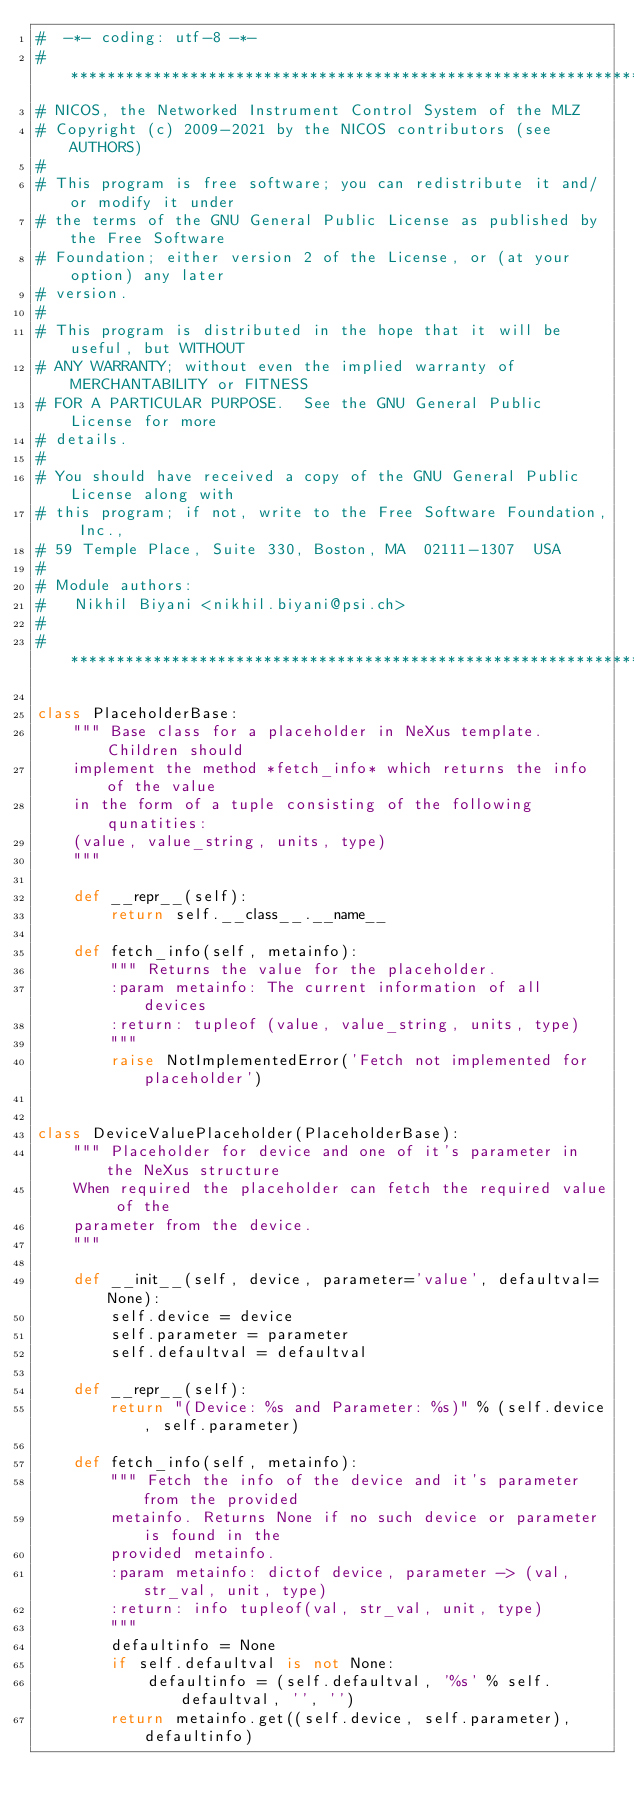<code> <loc_0><loc_0><loc_500><loc_500><_Python_>#  -*- coding: utf-8 -*-
# *****************************************************************************
# NICOS, the Networked Instrument Control System of the MLZ
# Copyright (c) 2009-2021 by the NICOS contributors (see AUTHORS)
#
# This program is free software; you can redistribute it and/or modify it under
# the terms of the GNU General Public License as published by the Free Software
# Foundation; either version 2 of the License, or (at your option) any later
# version.
#
# This program is distributed in the hope that it will be useful, but WITHOUT
# ANY WARRANTY; without even the implied warranty of MERCHANTABILITY or FITNESS
# FOR A PARTICULAR PURPOSE.  See the GNU General Public License for more
# details.
#
# You should have received a copy of the GNU General Public License along with
# this program; if not, write to the Free Software Foundation, Inc.,
# 59 Temple Place, Suite 330, Boston, MA  02111-1307  USA
#
# Module authors:
#   Nikhil Biyani <nikhil.biyani@psi.ch>
#
# *****************************************************************************

class PlaceholderBase:
    """ Base class for a placeholder in NeXus template. Children should
    implement the method *fetch_info* which returns the info of the value
    in the form of a tuple consisting of the following qunatities:
    (value, value_string, units, type)
    """

    def __repr__(self):
        return self.__class__.__name__

    def fetch_info(self, metainfo):
        """ Returns the value for the placeholder.
        :param metainfo: The current information of all devices
        :return: tupleof (value, value_string, units, type)
        """
        raise NotImplementedError('Fetch not implemented for placeholder')


class DeviceValuePlaceholder(PlaceholderBase):
    """ Placeholder for device and one of it's parameter in the NeXus structure
    When required the placeholder can fetch the required value of the
    parameter from the device.
    """

    def __init__(self, device, parameter='value', defaultval=None):
        self.device = device
        self.parameter = parameter
        self.defaultval = defaultval

    def __repr__(self):
        return "(Device: %s and Parameter: %s)" % (self.device, self.parameter)

    def fetch_info(self, metainfo):
        """ Fetch the info of the device and it's parameter from the provided
        metainfo. Returns None if no such device or parameter is found in the
        provided metainfo.
        :param metainfo: dictof device, parameter -> (val, str_val, unit, type)
        :return: info tupleof(val, str_val, unit, type)
        """
        defaultinfo = None
        if self.defaultval is not None:
            defaultinfo = (self.defaultval, '%s' % self.defaultval, '', '')
        return metainfo.get((self.device, self.parameter), defaultinfo)
</code> 